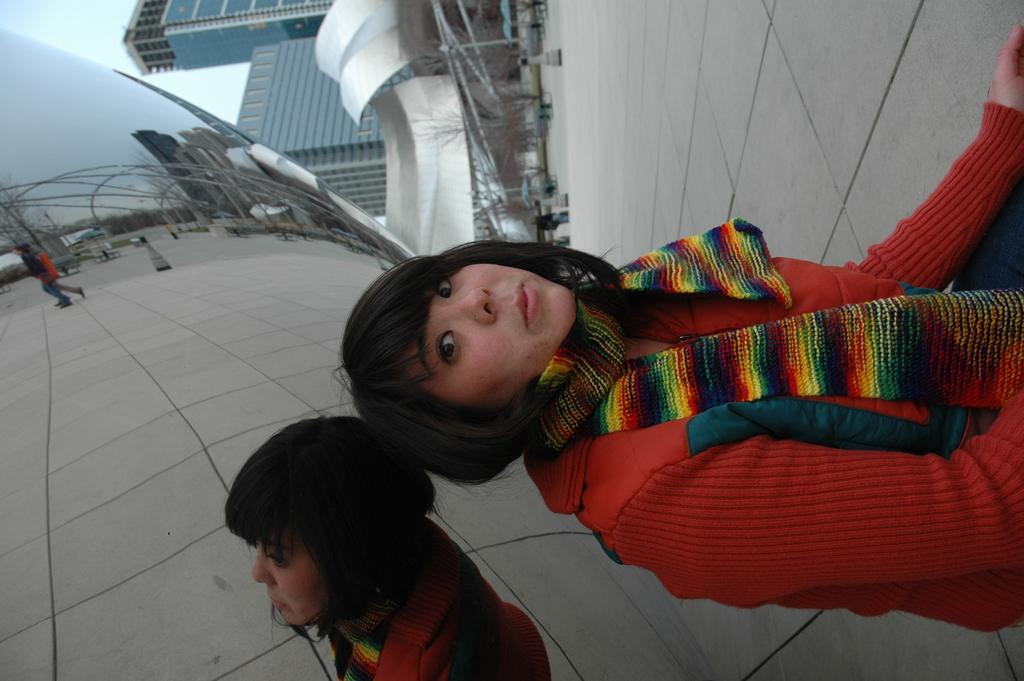Please provide a concise description of this image. In this image, we can see a woman is sitting, at the back we can see some buildings, and background is the sky. 